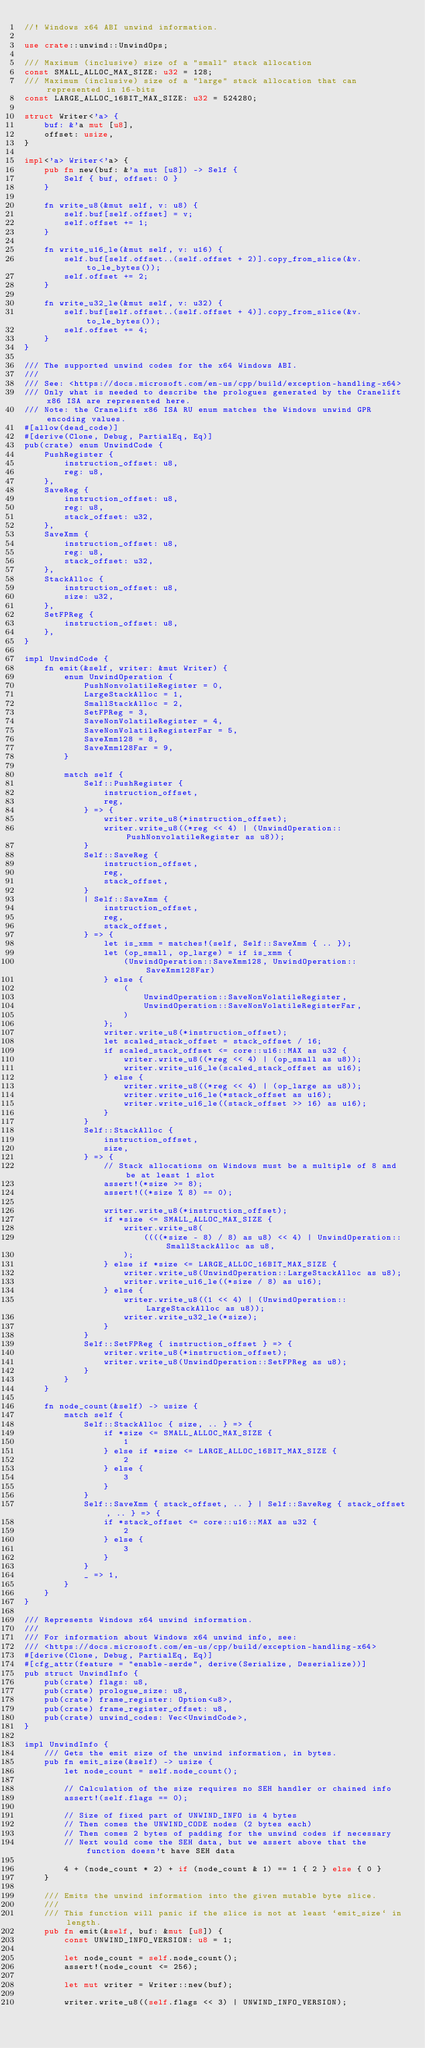<code> <loc_0><loc_0><loc_500><loc_500><_Rust_>//! Windows x64 ABI unwind information.

use crate::unwind::UnwindOps;

/// Maximum (inclusive) size of a "small" stack allocation
const SMALL_ALLOC_MAX_SIZE: u32 = 128;
/// Maximum (inclusive) size of a "large" stack allocation that can represented in 16-bits
const LARGE_ALLOC_16BIT_MAX_SIZE: u32 = 524280;

struct Writer<'a> {
    buf: &'a mut [u8],
    offset: usize,
}

impl<'a> Writer<'a> {
    pub fn new(buf: &'a mut [u8]) -> Self {
        Self { buf, offset: 0 }
    }

    fn write_u8(&mut self, v: u8) {
        self.buf[self.offset] = v;
        self.offset += 1;
    }

    fn write_u16_le(&mut self, v: u16) {
        self.buf[self.offset..(self.offset + 2)].copy_from_slice(&v.to_le_bytes());
        self.offset += 2;
    }

    fn write_u32_le(&mut self, v: u32) {
        self.buf[self.offset..(self.offset + 4)].copy_from_slice(&v.to_le_bytes());
        self.offset += 4;
    }
}

/// The supported unwind codes for the x64 Windows ABI.
///
/// See: <https://docs.microsoft.com/en-us/cpp/build/exception-handling-x64>
/// Only what is needed to describe the prologues generated by the Cranelift x86 ISA are represented here.
/// Note: the Cranelift x86 ISA RU enum matches the Windows unwind GPR encoding values.
#[allow(dead_code)]
#[derive(Clone, Debug, PartialEq, Eq)]
pub(crate) enum UnwindCode {
    PushRegister {
        instruction_offset: u8,
        reg: u8,
    },
    SaveReg {
        instruction_offset: u8,
        reg: u8,
        stack_offset: u32,
    },
    SaveXmm {
        instruction_offset: u8,
        reg: u8,
        stack_offset: u32,
    },
    StackAlloc {
        instruction_offset: u8,
        size: u32,
    },
    SetFPReg {
        instruction_offset: u8,
    },
}

impl UnwindCode {
    fn emit(&self, writer: &mut Writer) {
        enum UnwindOperation {
            PushNonvolatileRegister = 0,
            LargeStackAlloc = 1,
            SmallStackAlloc = 2,
            SetFPReg = 3,
            SaveNonVolatileRegister = 4,
            SaveNonVolatileRegisterFar = 5,
            SaveXmm128 = 8,
            SaveXmm128Far = 9,
        }

        match self {
            Self::PushRegister {
                instruction_offset,
                reg,
            } => {
                writer.write_u8(*instruction_offset);
                writer.write_u8((*reg << 4) | (UnwindOperation::PushNonvolatileRegister as u8));
            }
            Self::SaveReg {
                instruction_offset,
                reg,
                stack_offset,
            }
            | Self::SaveXmm {
                instruction_offset,
                reg,
                stack_offset,
            } => {
                let is_xmm = matches!(self, Self::SaveXmm { .. });
                let (op_small, op_large) = if is_xmm {
                    (UnwindOperation::SaveXmm128, UnwindOperation::SaveXmm128Far)
                } else {
                    (
                        UnwindOperation::SaveNonVolatileRegister,
                        UnwindOperation::SaveNonVolatileRegisterFar,
                    )
                };
                writer.write_u8(*instruction_offset);
                let scaled_stack_offset = stack_offset / 16;
                if scaled_stack_offset <= core::u16::MAX as u32 {
                    writer.write_u8((*reg << 4) | (op_small as u8));
                    writer.write_u16_le(scaled_stack_offset as u16);
                } else {
                    writer.write_u8((*reg << 4) | (op_large as u8));
                    writer.write_u16_le(*stack_offset as u16);
                    writer.write_u16_le((stack_offset >> 16) as u16);
                }
            }
            Self::StackAlloc {
                instruction_offset,
                size,
            } => {
                // Stack allocations on Windows must be a multiple of 8 and be at least 1 slot
                assert!(*size >= 8);
                assert!((*size % 8) == 0);

                writer.write_u8(*instruction_offset);
                if *size <= SMALL_ALLOC_MAX_SIZE {
                    writer.write_u8(
                        ((((*size - 8) / 8) as u8) << 4) | UnwindOperation::SmallStackAlloc as u8,
                    );
                } else if *size <= LARGE_ALLOC_16BIT_MAX_SIZE {
                    writer.write_u8(UnwindOperation::LargeStackAlloc as u8);
                    writer.write_u16_le((*size / 8) as u16);
                } else {
                    writer.write_u8((1 << 4) | (UnwindOperation::LargeStackAlloc as u8));
                    writer.write_u32_le(*size);
                }
            }
            Self::SetFPReg { instruction_offset } => {
                writer.write_u8(*instruction_offset);
                writer.write_u8(UnwindOperation::SetFPReg as u8);
            }
        }
    }

    fn node_count(&self) -> usize {
        match self {
            Self::StackAlloc { size, .. } => {
                if *size <= SMALL_ALLOC_MAX_SIZE {
                    1
                } else if *size <= LARGE_ALLOC_16BIT_MAX_SIZE {
                    2
                } else {
                    3
                }
            }
            Self::SaveXmm { stack_offset, .. } | Self::SaveReg { stack_offset, .. } => {
                if *stack_offset <= core::u16::MAX as u32 {
                    2
                } else {
                    3
                }
            }
            _ => 1,
        }
    }
}

/// Represents Windows x64 unwind information.
///
/// For information about Windows x64 unwind info, see:
/// <https://docs.microsoft.com/en-us/cpp/build/exception-handling-x64>
#[derive(Clone, Debug, PartialEq, Eq)]
#[cfg_attr(feature = "enable-serde", derive(Serialize, Deserialize))]
pub struct UnwindInfo {
    pub(crate) flags: u8,
    pub(crate) prologue_size: u8,
    pub(crate) frame_register: Option<u8>,
    pub(crate) frame_register_offset: u8,
    pub(crate) unwind_codes: Vec<UnwindCode>,
}

impl UnwindInfo {
    /// Gets the emit size of the unwind information, in bytes.
    pub fn emit_size(&self) -> usize {
        let node_count = self.node_count();

        // Calculation of the size requires no SEH handler or chained info
        assert!(self.flags == 0);

        // Size of fixed part of UNWIND_INFO is 4 bytes
        // Then comes the UNWIND_CODE nodes (2 bytes each)
        // Then comes 2 bytes of padding for the unwind codes if necessary
        // Next would come the SEH data, but we assert above that the function doesn't have SEH data

        4 + (node_count * 2) + if (node_count & 1) == 1 { 2 } else { 0 }
    }

    /// Emits the unwind information into the given mutable byte slice.
    ///
    /// This function will panic if the slice is not at least `emit_size` in length.
    pub fn emit(&self, buf: &mut [u8]) {
        const UNWIND_INFO_VERSION: u8 = 1;

        let node_count = self.node_count();
        assert!(node_count <= 256);

        let mut writer = Writer::new(buf);

        writer.write_u8((self.flags << 3) | UNWIND_INFO_VERSION);</code> 